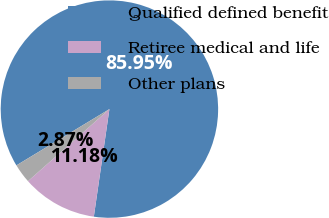<chart> <loc_0><loc_0><loc_500><loc_500><pie_chart><fcel>Qualified defined benefit<fcel>Retiree medical and life<fcel>Other plans<nl><fcel>85.95%<fcel>11.18%<fcel>2.87%<nl></chart> 